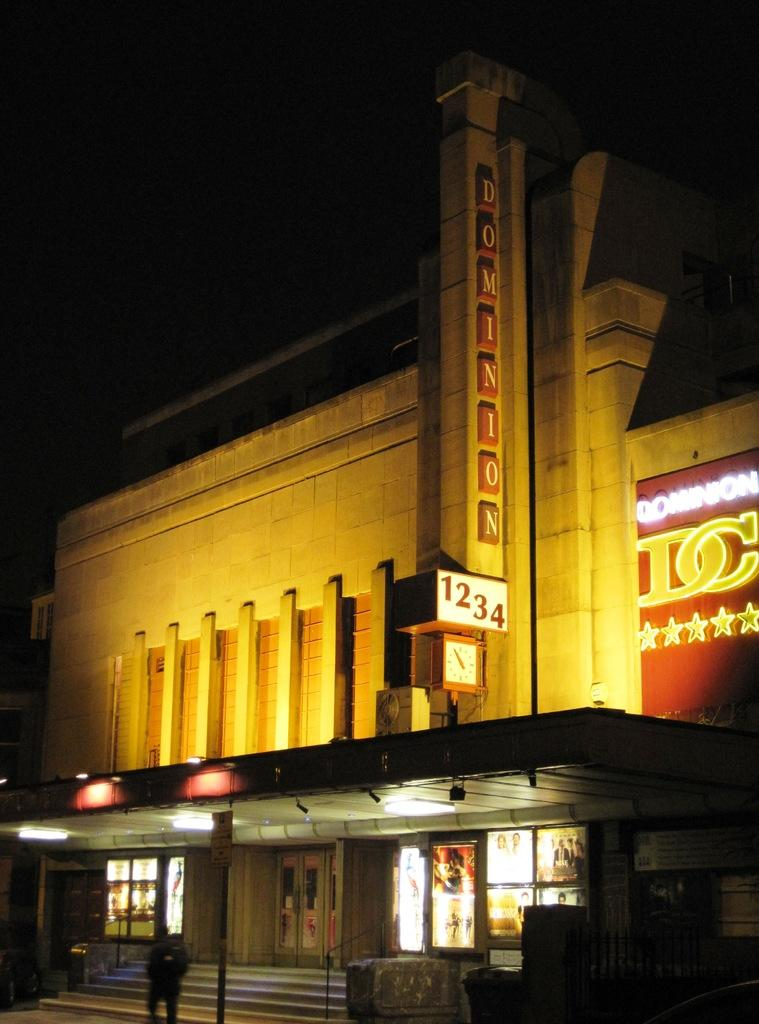What is the person in the image doing? There is a person standing on the ground in the image. What can be seen in the image besides the person? There are stairs, lights, a building, boards on the building, and a dark sky in the background. What is the purpose of the stairs in the image? The stairs in the image provide access to the building. What is the condition of the building in the image? The building has boards on it, which may indicate that it is under construction or renovation. What type of soup is being served in the basket in the image? There is no soup or basket present in the image. 